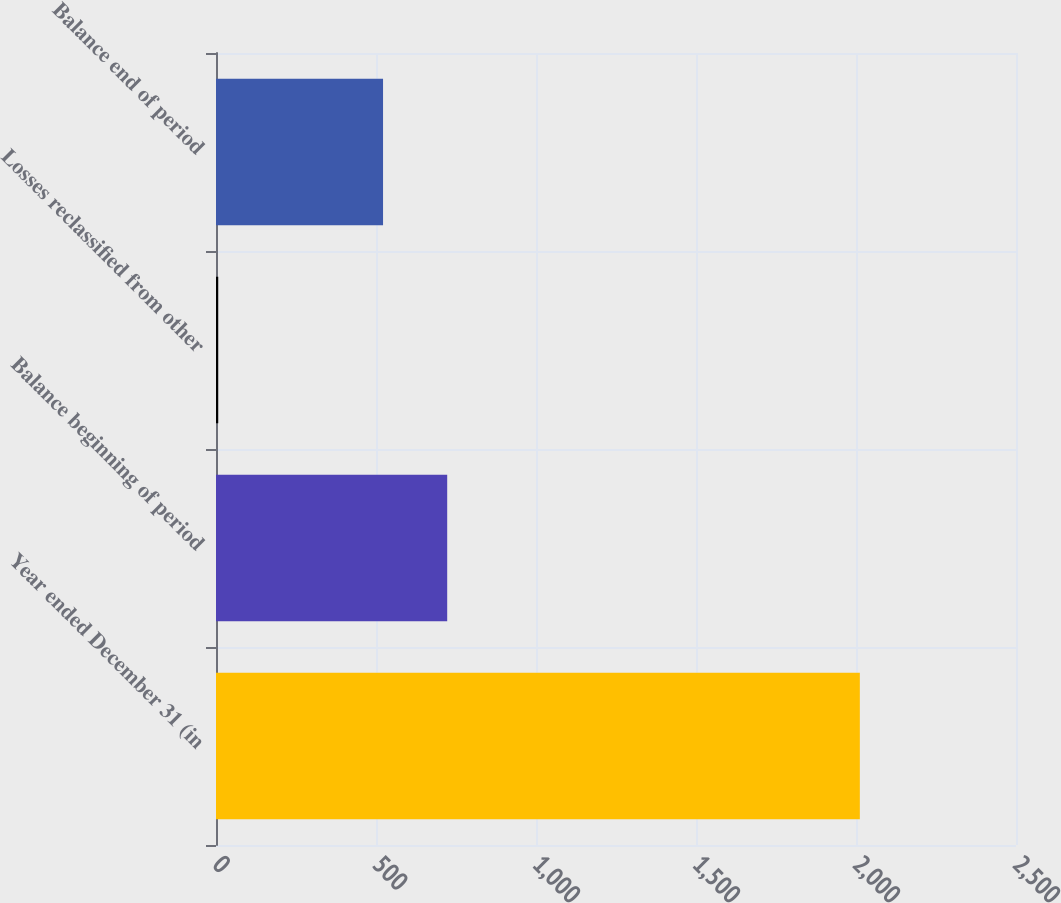<chart> <loc_0><loc_0><loc_500><loc_500><bar_chart><fcel>Year ended December 31 (in<fcel>Balance beginning of period<fcel>Losses reclassified from other<fcel>Balance end of period<nl><fcel>2012<fcel>722.5<fcel>7<fcel>522<nl></chart> 